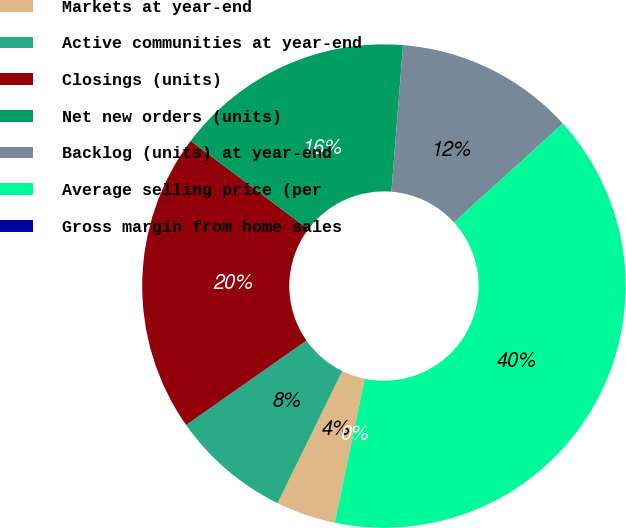<chart> <loc_0><loc_0><loc_500><loc_500><pie_chart><fcel>Markets at year-end<fcel>Active communities at year-end<fcel>Closings (units)<fcel>Net new orders (units)<fcel>Backlog (units) at year-end<fcel>Average selling price (per<fcel>Gross margin from home sales<nl><fcel>4.0%<fcel>8.0%<fcel>20.0%<fcel>16.0%<fcel>12.0%<fcel>39.99%<fcel>0.0%<nl></chart> 